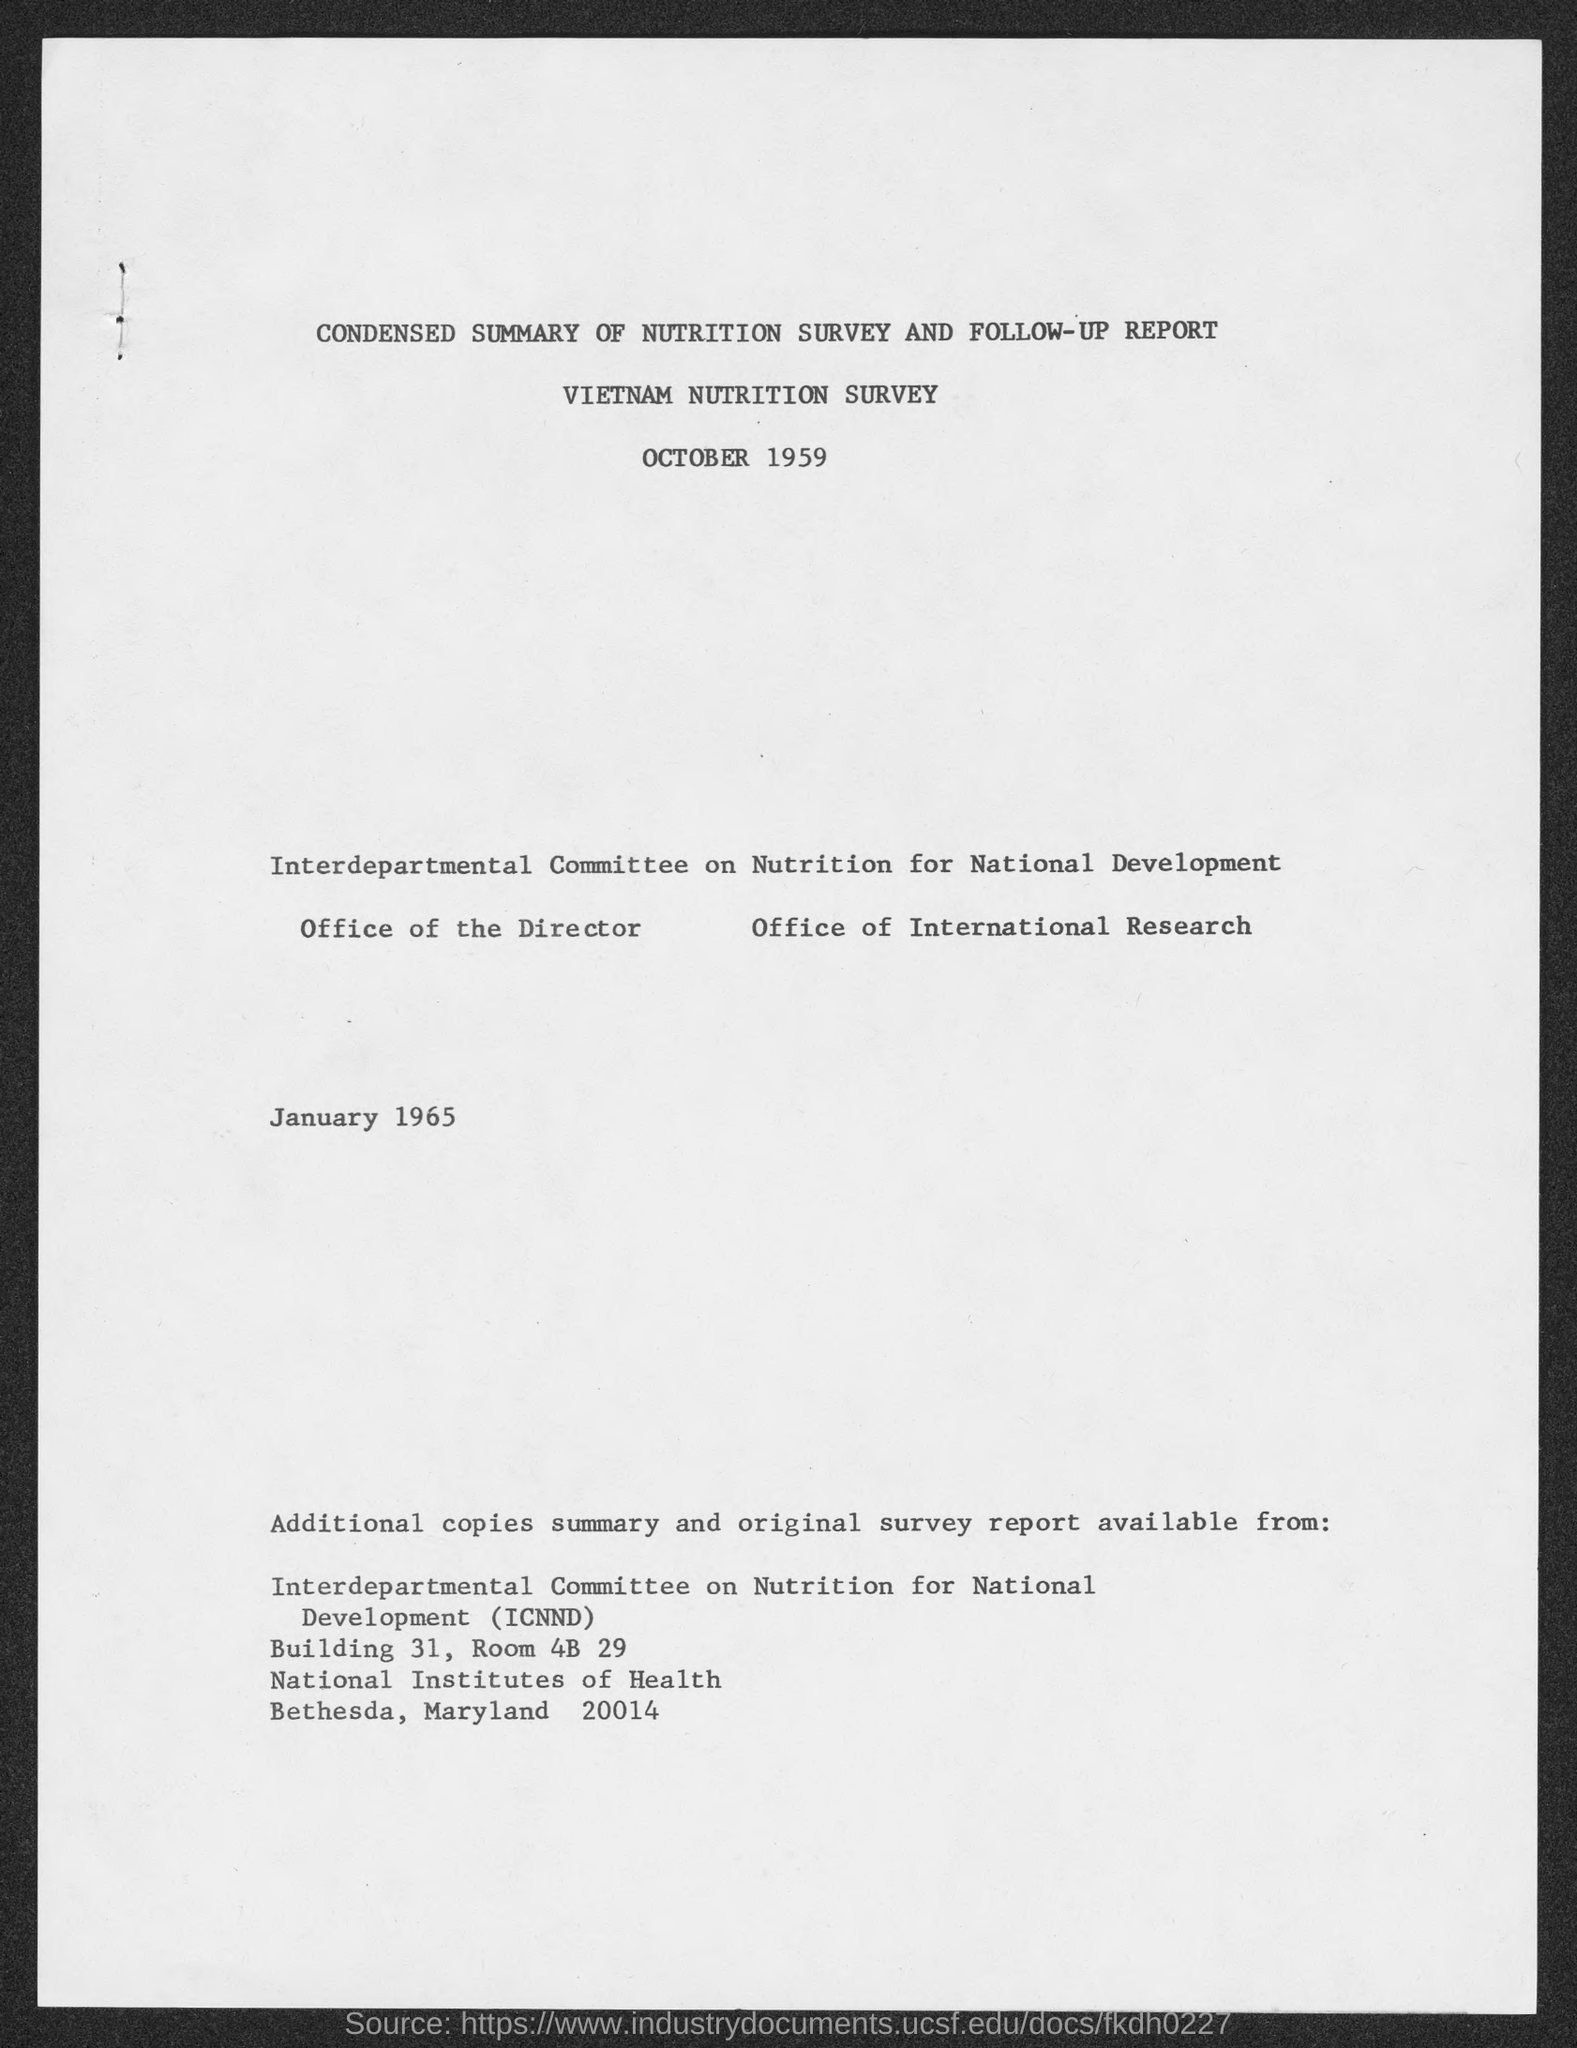What is the document title?
Ensure brevity in your answer.  Condensed summary of nutrition survey and follow-up report. When is Nutrition Survey?
Keep it short and to the point. OCTOBER 1959. What is the name of the survey?
Ensure brevity in your answer.  Vietnam nutrition survey. What does ICNND stand for?
Provide a short and direct response. Interdepartmental committee on nutrition for national development. 